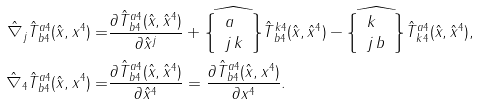<formula> <loc_0><loc_0><loc_500><loc_500>\hat { \nabla } _ { j } \hat { T } ^ { a 4 } _ { \, b 4 } ( \hat { x } , x ^ { 4 } ) = & \frac { \partial \hat { T } ^ { a 4 } _ { \, b 4 } ( \hat { x } , \hat { x } ^ { 4 } ) } { \partial \hat { x } ^ { j } } + \widehat { \left \{ \begin{array} { l } a \\ j \, k \end{array} \right \} } \hat { T } ^ { k 4 } _ { \, b 4 } ( \hat { x } , \hat { x } ^ { 4 } ) - \widehat { \left \{ \begin{array} { l } k \\ j \, b \end{array} \right \} } \hat { T } ^ { a 4 } _ { \, k 4 } ( \hat { x } , \hat { x } ^ { 4 } ) , \\ \hat { \nabla } _ { 4 } \hat { T } ^ { a 4 } _ { \, b 4 } ( \hat { x } , x ^ { 4 } ) = & \frac { \partial \hat { T } ^ { a 4 } _ { \, b 4 } ( \hat { x } , \hat { x } ^ { 4 } ) } { \partial \hat { x } ^ { 4 } } = \frac { \partial \hat { T } ^ { a 4 } _ { \, b 4 } ( \hat { x } , { x } ^ { 4 } ) } { \partial { x } ^ { 4 } } .</formula> 